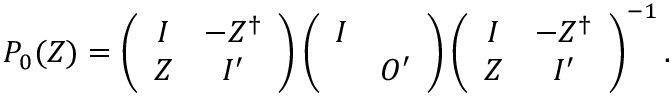Convert formula to latex. <formula><loc_0><loc_0><loc_500><loc_500>P _ { 0 } ( Z ) = \left ( \begin{array} { c c } { I } & { { - Z ^ { \dag } } } \\ { Z } & { { I ^ { \prime } } } \end{array} \right ) \left ( \begin{array} { c c } { I } & { { O ^ { \prime } } } \end{array} \right ) \left ( \begin{array} { c c } { I } & { { - Z ^ { \dag } } } \\ { Z } & { { I ^ { \prime } } } \end{array} \right ) ^ { - 1 } .</formula> 